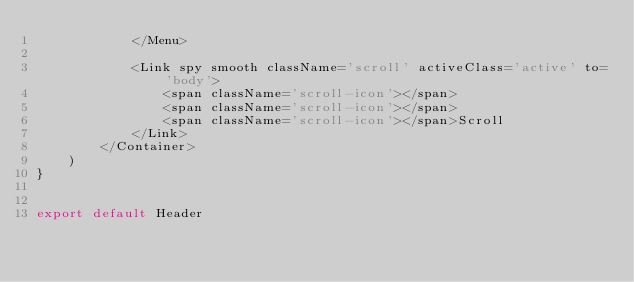Convert code to text. <code><loc_0><loc_0><loc_500><loc_500><_JavaScript_>            </Menu>

            <Link spy smooth className='scroll' activeClass='active' to='body'>
                <span className='scroll-icon'></span>
                <span className='scroll-icon'></span>
                <span className='scroll-icon'></span>Scroll
            </Link>
        </Container>
    )
}


export default Header
</code> 